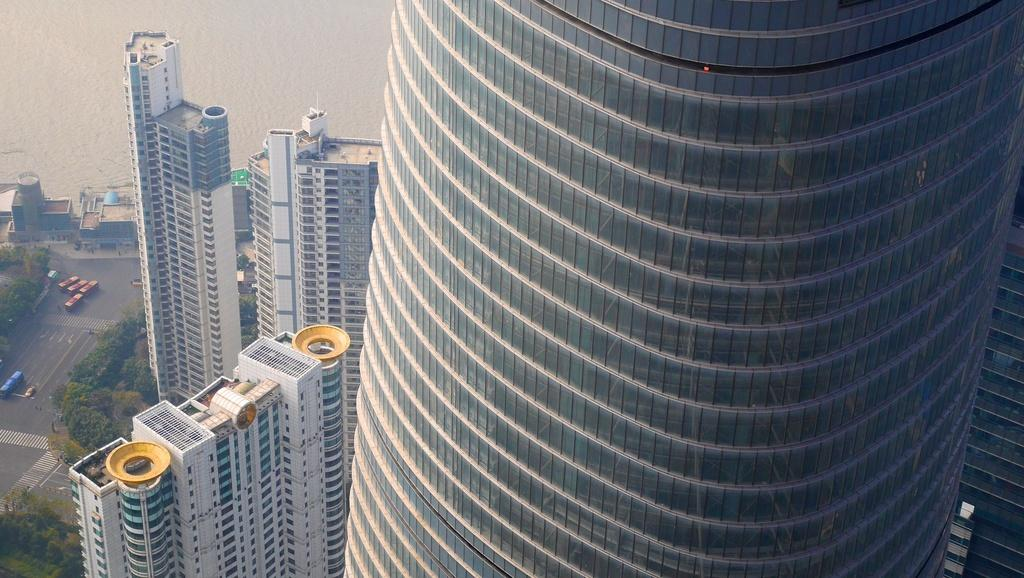What type of structures can be seen in the image? There are buildings in the image. What natural elements are present in the image? There are trees in the image. What man-made objects can be seen in the image? There are vehicles in the image. What body of water is visible in the image? There is water visible in the image. How many quinces are hanging from the trees in the image? There are no quinces present in the image, as it only features trees and not fruit-bearing trees. Can you see a zebra walking near the buildings in the image? There is no zebra present in the image; it only features buildings, trees, vehicles, and water. 